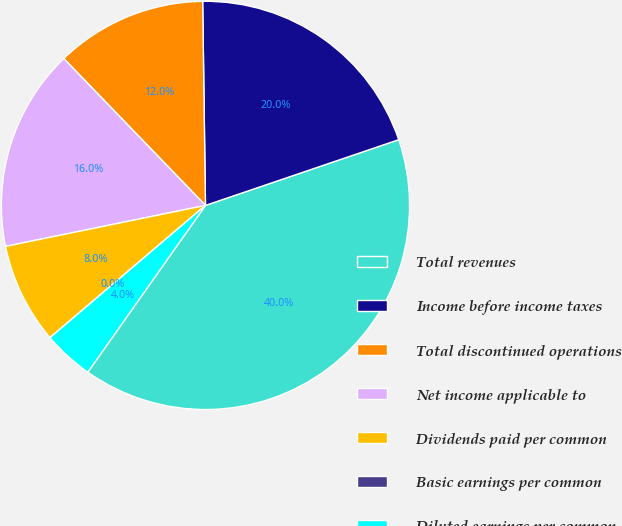<chart> <loc_0><loc_0><loc_500><loc_500><pie_chart><fcel>Total revenues<fcel>Income before income taxes<fcel>Total discontinued operations<fcel>Net income applicable to<fcel>Dividends paid per common<fcel>Basic earnings per common<fcel>Diluted earnings per common<nl><fcel>40.0%<fcel>20.0%<fcel>12.0%<fcel>16.0%<fcel>8.0%<fcel>0.0%<fcel>4.0%<nl></chart> 